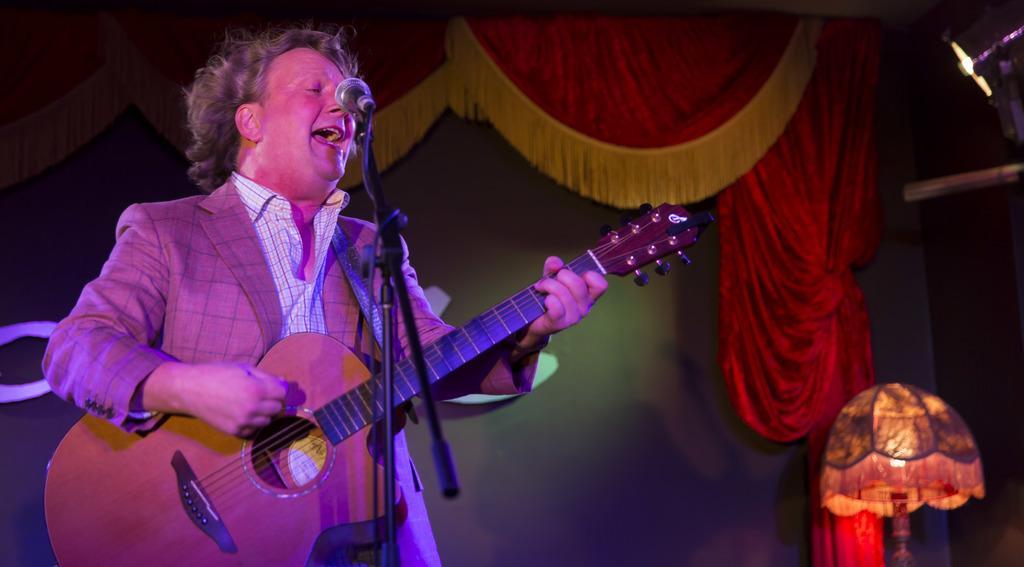Please provide a concise description of this image. In this image there is a man singing and playing guitar. In front of him there is a microphone. To the below right corner there is a lamp. In the background there is wall and curtains. 